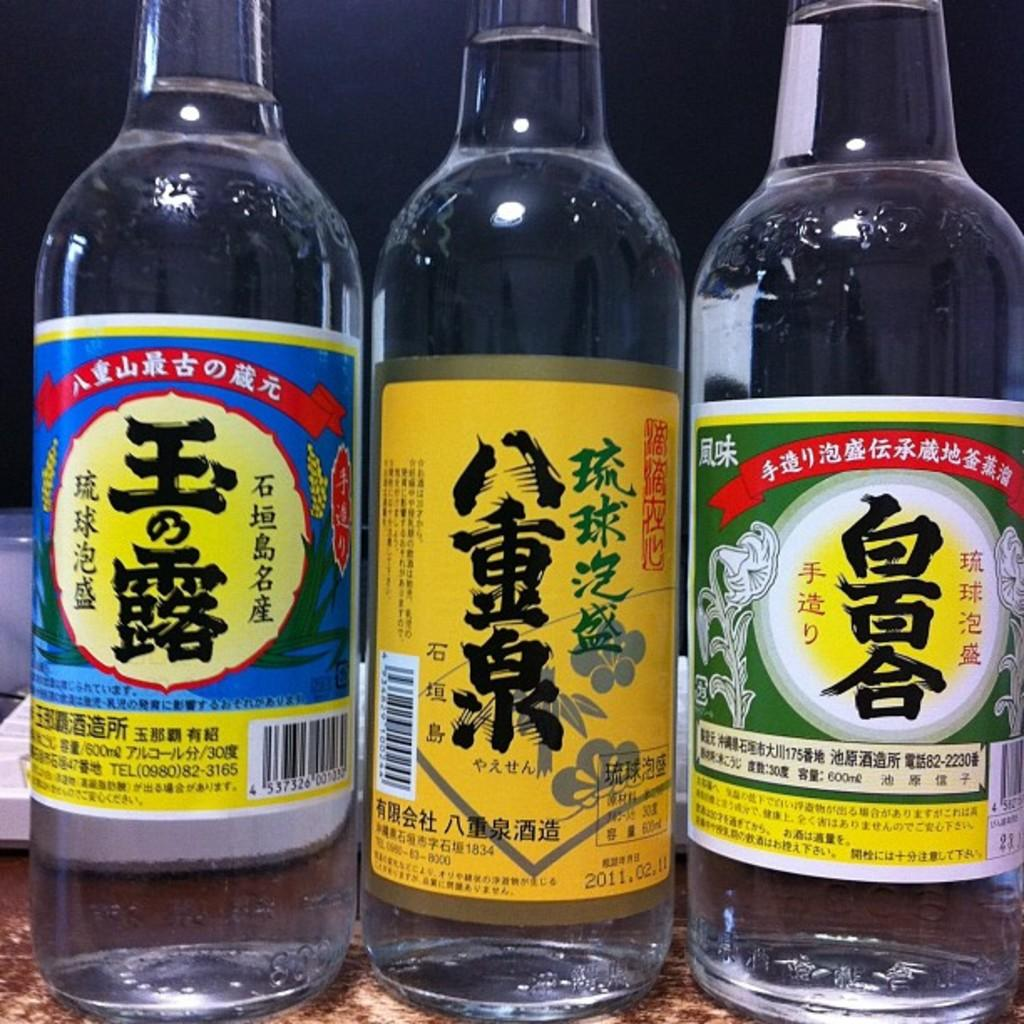<image>
Relay a brief, clear account of the picture shown. Three bottles with clear liquid in them and japanese or chinese writing 